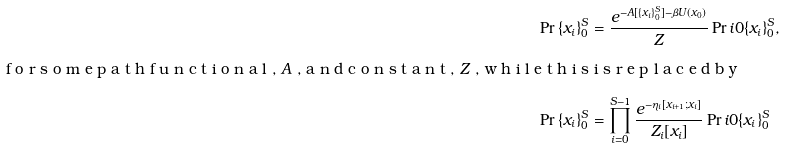Convert formula to latex. <formula><loc_0><loc_0><loc_500><loc_500>\Pr { \{ x _ { i } \} _ { 0 } ^ { S } } & = \frac { e ^ { - A [ \{ x _ { i } \} _ { 0 } ^ { S } ] - \beta U ( x _ { 0 } ) } } { Z } \Pr i { 0 } { \{ x _ { i } \} _ { 0 } ^ { S } } , \\ \intertext { f o r s o m e p a t h f u n c t i o n a l , $ A $ , a n d c o n s t a n t , $ Z $ , w h i l e t h i s i s r e p l a c e d b y } \Pr { \{ x _ { i } \} _ { 0 } ^ { S } } & = \prod _ { i = 0 } ^ { S - 1 } \frac { e ^ { - \eta _ { i } [ x _ { i + 1 } ; x _ { i } ] } } { Z _ { i } [ x _ { i } ] } \Pr i { 0 } { \{ x _ { i } \} _ { 0 } ^ { S } }</formula> 